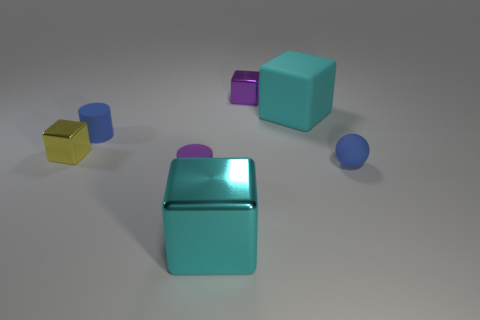Subtract 2 cubes. How many cubes are left? 2 Add 3 large green blocks. How many objects exist? 10 Subtract all green cubes. Subtract all gray cylinders. How many cubes are left? 4 Subtract all balls. How many objects are left? 6 Subtract all big gray spheres. Subtract all cyan metallic things. How many objects are left? 6 Add 3 blue objects. How many blue objects are left? 5 Add 7 tiny purple shiny things. How many tiny purple shiny things exist? 8 Subtract 0 gray cylinders. How many objects are left? 7 